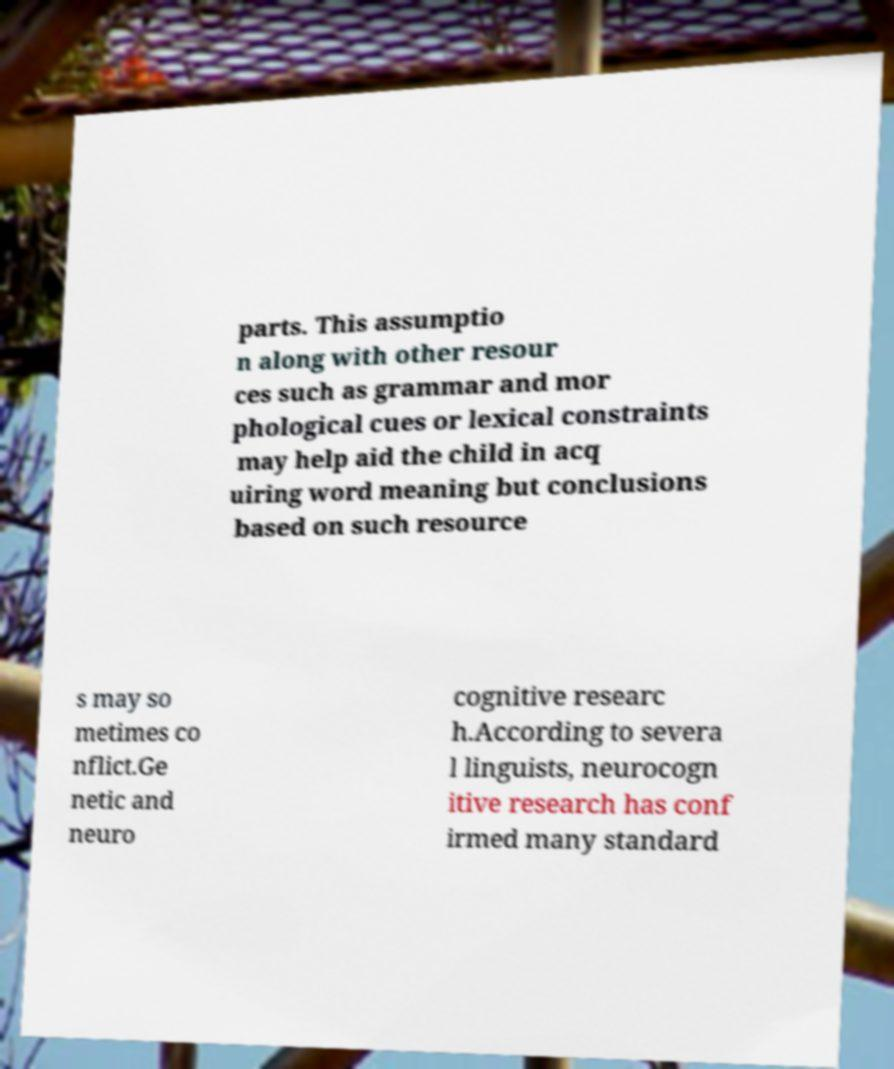For documentation purposes, I need the text within this image transcribed. Could you provide that? parts. This assumptio n along with other resour ces such as grammar and mor phological cues or lexical constraints may help aid the child in acq uiring word meaning but conclusions based on such resource s may so metimes co nflict.Ge netic and neuro cognitive researc h.According to severa l linguists, neurocogn itive research has conf irmed many standard 